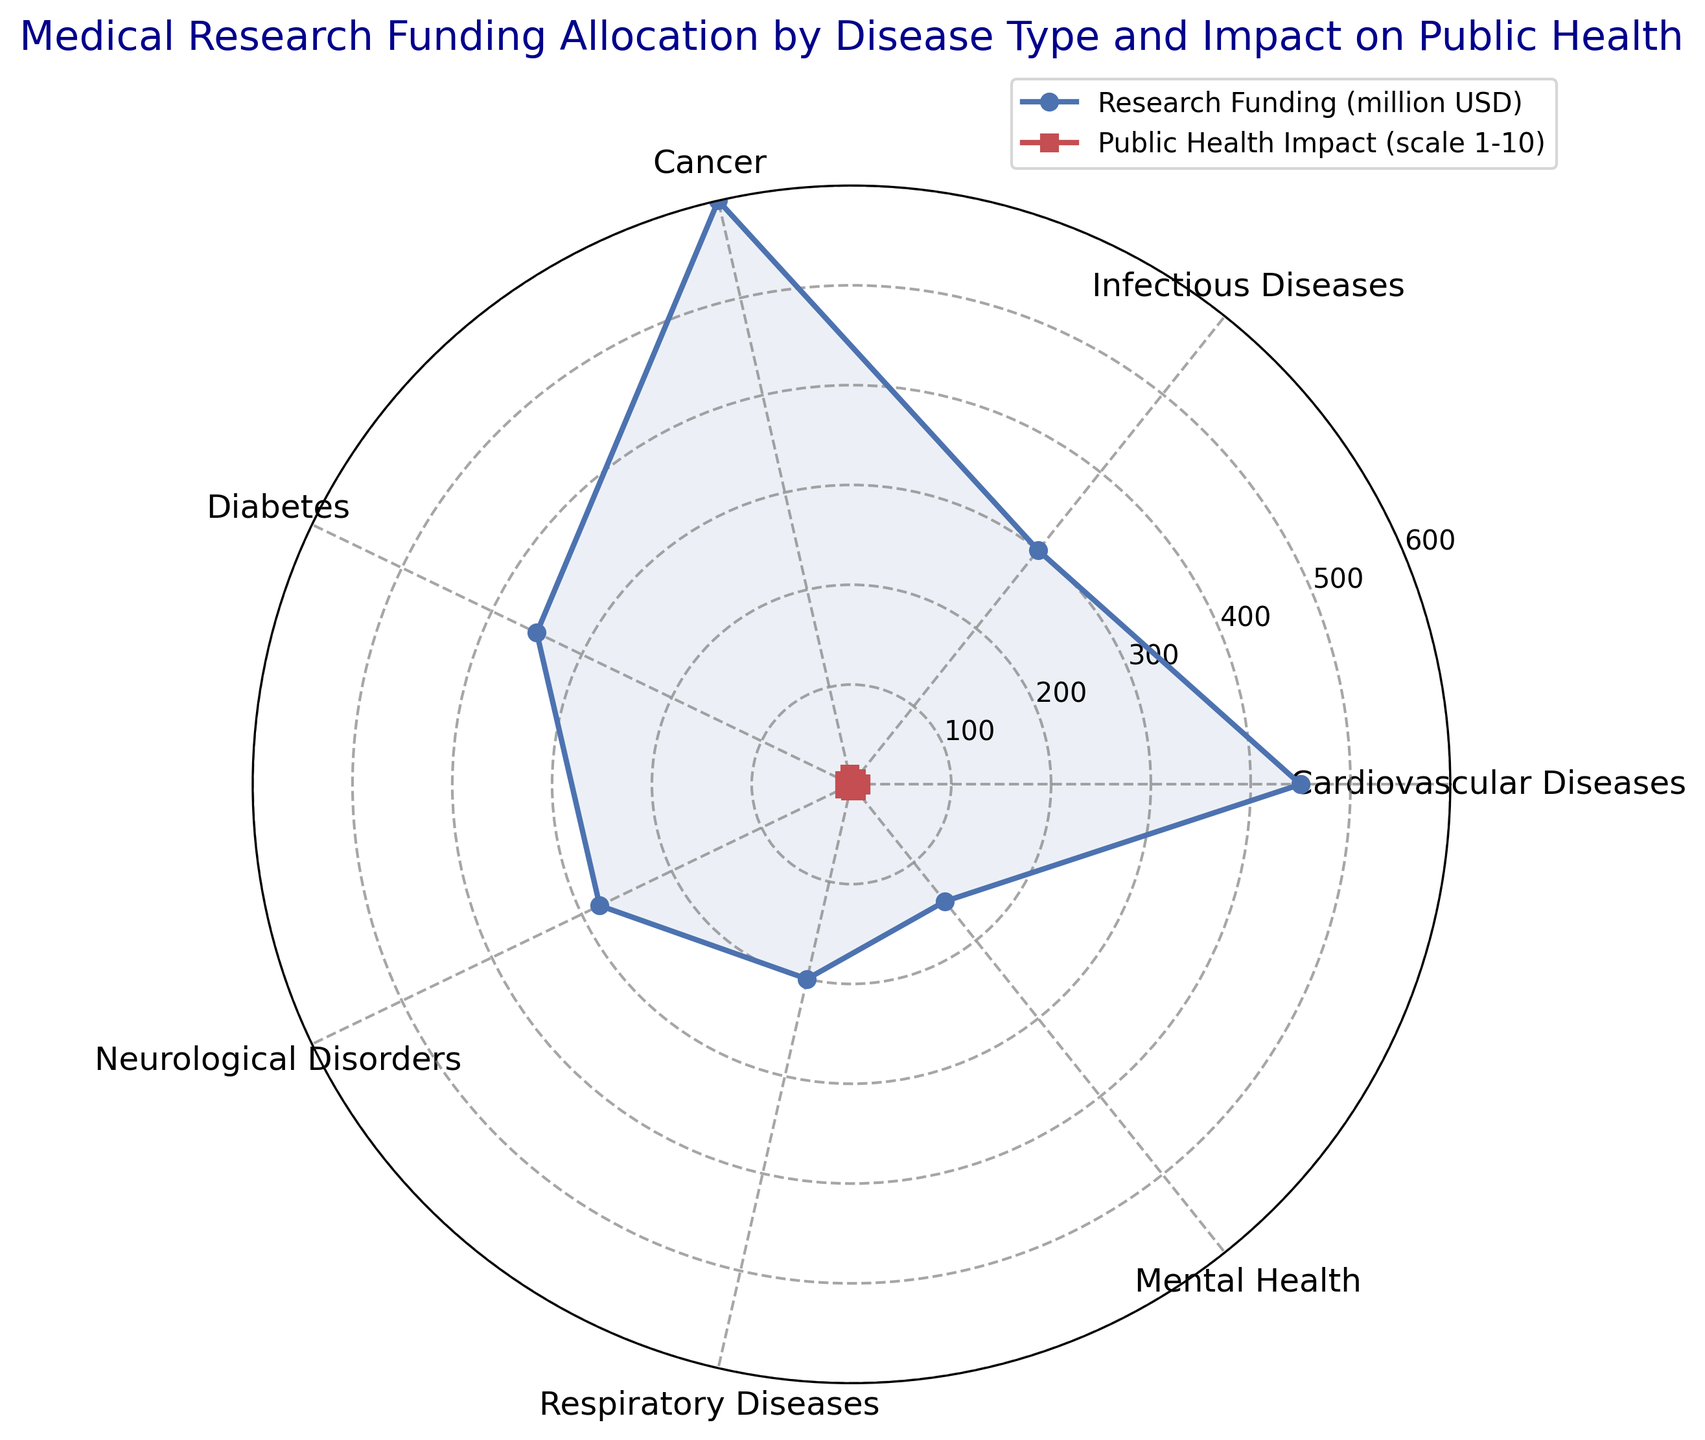What's the total research funding for Cardiovascular Diseases and Cancer? To find the total research funding for Cardiovascular Diseases and Cancer, add the allocated amounts for each. Cardiovascular Diseases have 450 million USD allocated, and Cancer has 600 million USD allocated. Therefore, the total research funding is 450 + 600 = 1050 million USD.
Answer: 1050 million USD Which disease type has the highest public health impact score? The public health impact scores for each disease type are as follows: Cardiovascular Diseases (9), Infectious Diseases (7), Cancer (10), Diabetes (8), Neurological Disorders (8), Respiratory Diseases (6), and Mental Health (7). The highest score is 10, which is for Cancer.
Answer: Cancer Compare the research funding for Respiratory Diseases to that for Mental Health. Which is higher? The allocated research funding for Respiratory Diseases is 200 million USD, while for Mental Health, it is 150 million USD. Since 200 > 150, Respiratory Diseases receive higher funding than Mental Health.
Answer: Respiratory Diseases Is the public health impact score for Diabetes greater than or equal to the combined score for Mental Health and Respiratory Diseases? The public health impact score for Diabetes is 8. The combined score for Mental Health (7) and Respiratory Diseases (6) is 7 + 6 = 13. Since 8 < 13, the impact score for Diabetes is not greater than or equal to the combined score for Mental Health and Respiratory Diseases.
Answer: No What is the difference between the highest and the lowest research funding? The highest research funding is 600 million USD for Cancer, and the lowest is 150 million USD for Mental Health. The difference between them is 600 - 150 = 450 million USD.
Answer: 450 million USD Compare the visual sizes of the red and blue areas for Cardiovascular Diseases. Which is larger? Cardiovascular Diseases are represented by blue (research funding) and red (public health impact). In the radar chart, the blue area has a value of 450 million USD, and the red area has a score of 9. Visually inspecting the chart, the blue (research funding) area is larger than the red (public health impact) area for Cardiovascular Diseases.
Answer: Blue (research funding) Is the public health impact score of Cancer the highest among all disease types and also receiving the most research funding? Yes, Cancer has the highest public health impact score of 10 and also receives the most research funding at 600 million USD.
Answer: Yes How much more research funding does Cancer receive compared to Neurological Disorders? The research funding for Cancer is 600 million USD and for Neurological Disorders is 280 million USD. The difference is 600 - 280 = 320 million USD.
Answer: 320 million USD Are more disease types clustered close together for research funding or public health impact? By visually inspecting the radar chart, we see that the lines for research funding (blue) and public health impact (red) have varying distances from the center. The red areas (public health impact) are more clustered around 7-10, while blue areas (research funding) range more widely. Thus, disease types are more clustered together for public health impact.
Answer: Public health impact 